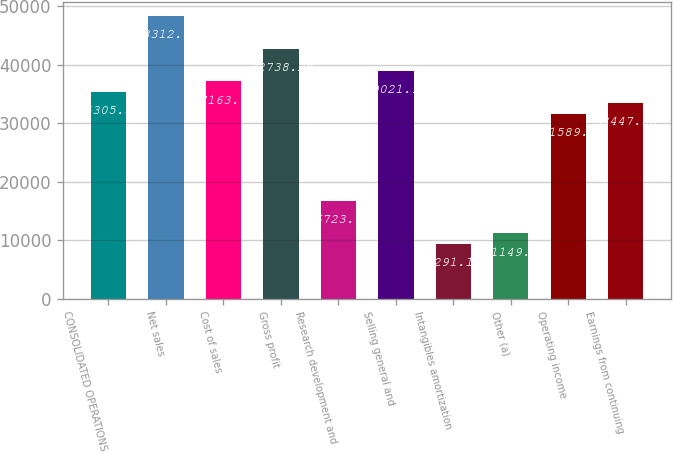<chart> <loc_0><loc_0><loc_500><loc_500><bar_chart><fcel>CONSOLIDATED OPERATIONS<fcel>Net sales<fcel>Cost of sales<fcel>Gross profit<fcel>Research development and<fcel>Selling general and<fcel>Intangibles amortization<fcel>Other (a)<fcel>Operating income<fcel>Earnings from continuing<nl><fcel>35305.6<fcel>48312.8<fcel>37163.7<fcel>42738.3<fcel>16723.8<fcel>39021.9<fcel>9291.12<fcel>11149.3<fcel>31589.2<fcel>33447.4<nl></chart> 